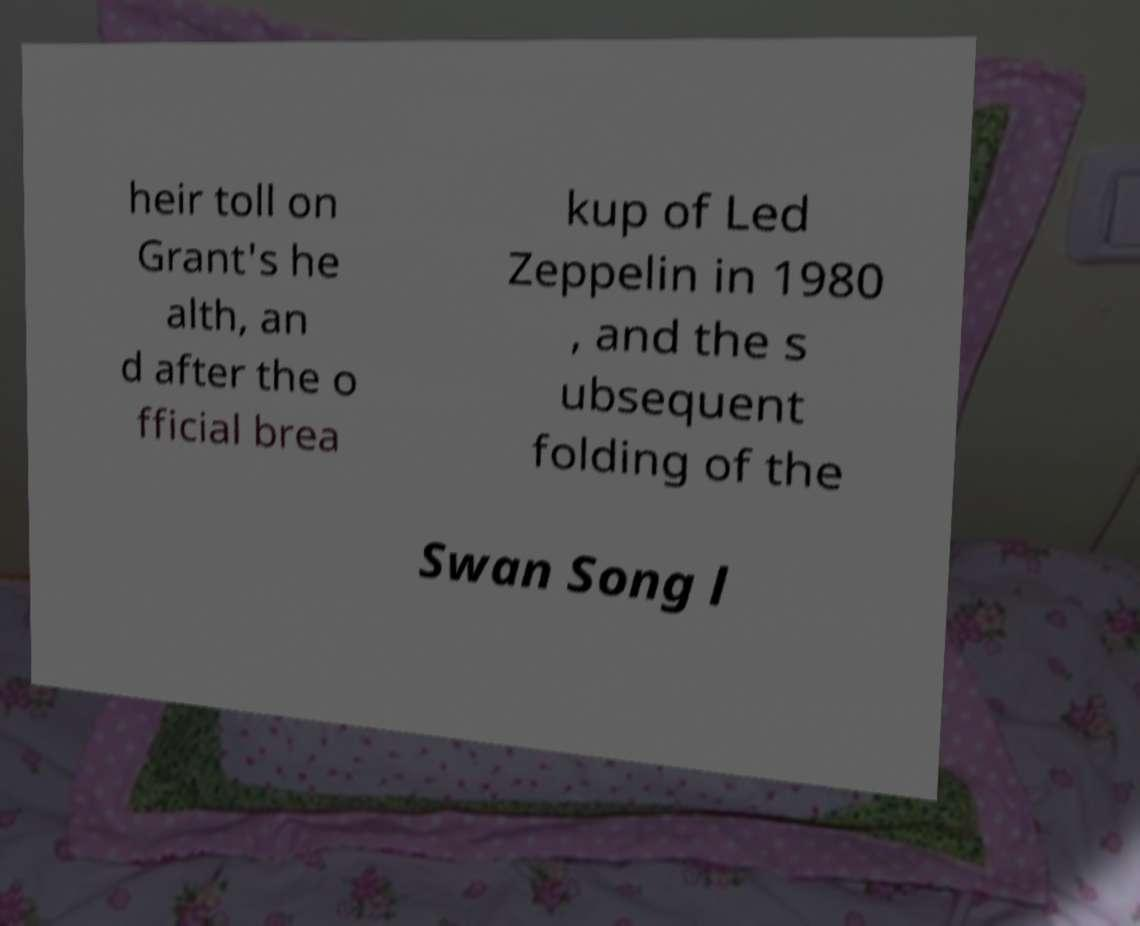There's text embedded in this image that I need extracted. Can you transcribe it verbatim? heir toll on Grant's he alth, an d after the o fficial brea kup of Led Zeppelin in 1980 , and the s ubsequent folding of the Swan Song l 